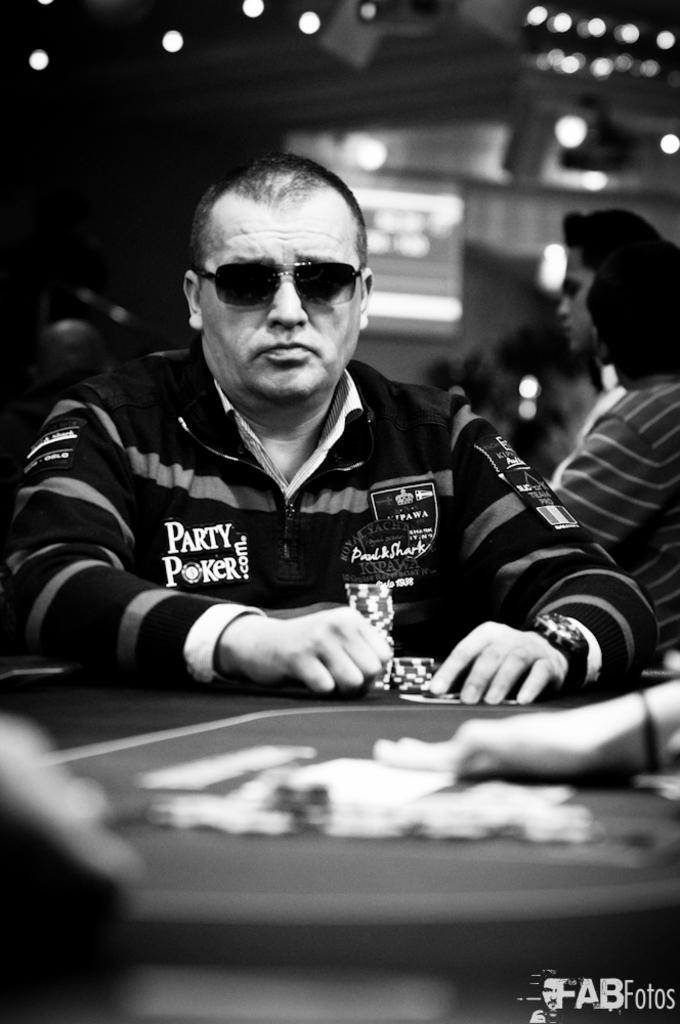What is the main subject of the image? The main subject of the image is a guy sitting on a poker table. What is the guy doing with his hands? The guy is holding coins in his hands. Can you describe the people in the background? There are people standing in the background. What can be seen attached to the roof? There are lights attached to the roof. How many pizzas are being served on the poker table? There is no mention of pizzas in the image; the main subject is a guy sitting on a poker table holding coins. What impulse caused the guy to sit on the poker table? The image does not provide information about the guy's motivation for sitting on the poker table. 